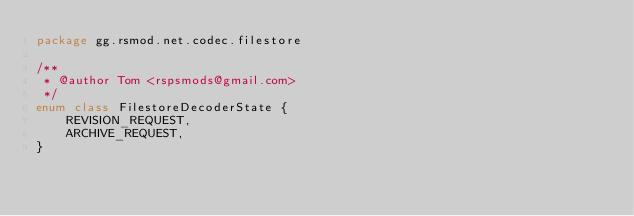Convert code to text. <code><loc_0><loc_0><loc_500><loc_500><_Kotlin_>package gg.rsmod.net.codec.filestore

/**
 * @author Tom <rspsmods@gmail.com>
 */
enum class FilestoreDecoderState {
    REVISION_REQUEST,
    ARCHIVE_REQUEST,
}</code> 